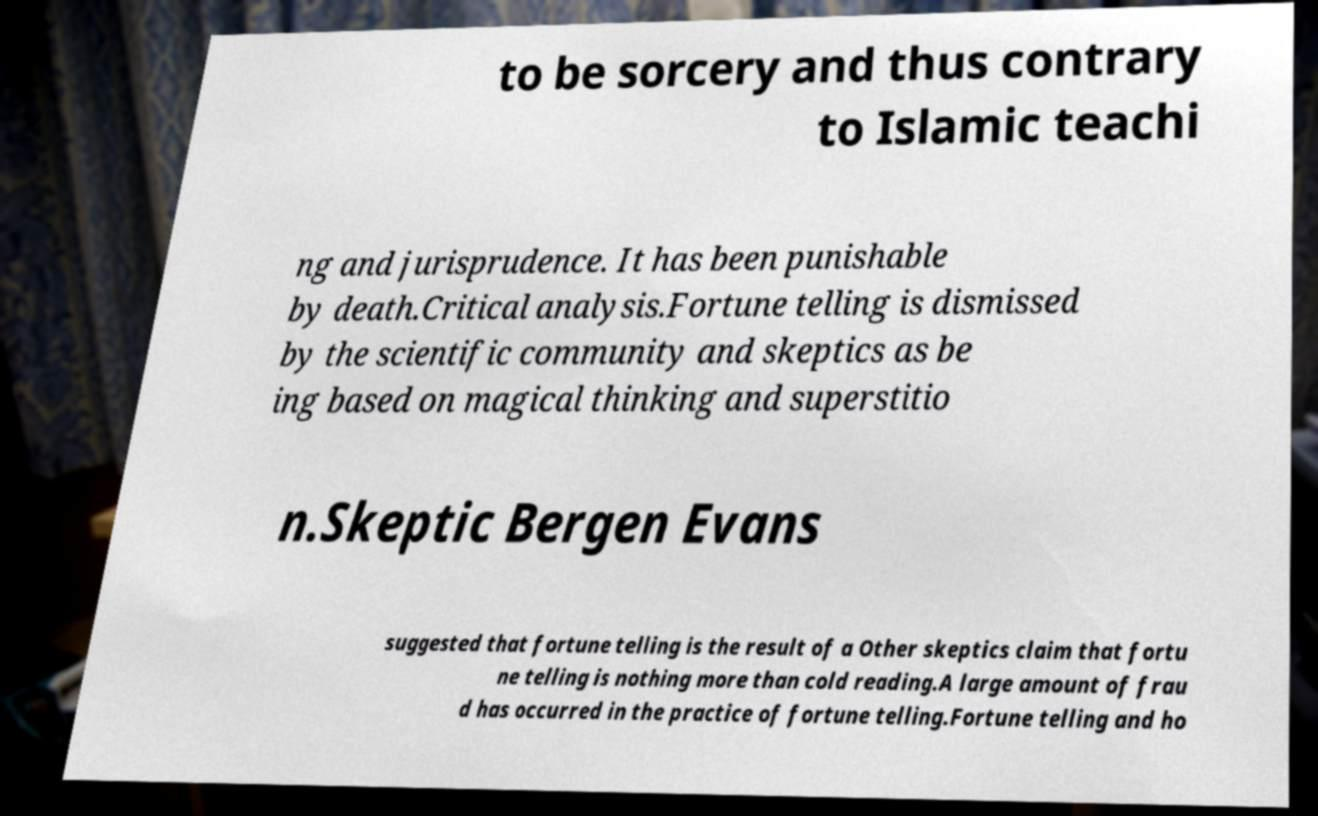Please read and relay the text visible in this image. What does it say? to be sorcery and thus contrary to Islamic teachi ng and jurisprudence. It has been punishable by death.Critical analysis.Fortune telling is dismissed by the scientific community and skeptics as be ing based on magical thinking and superstitio n.Skeptic Bergen Evans suggested that fortune telling is the result of a Other skeptics claim that fortu ne telling is nothing more than cold reading.A large amount of frau d has occurred in the practice of fortune telling.Fortune telling and ho 